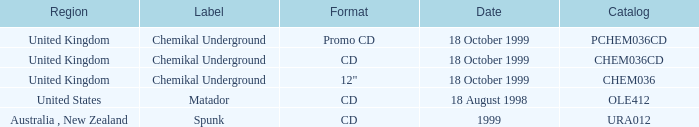What date is associated with the Spunk label? 1999.0. 